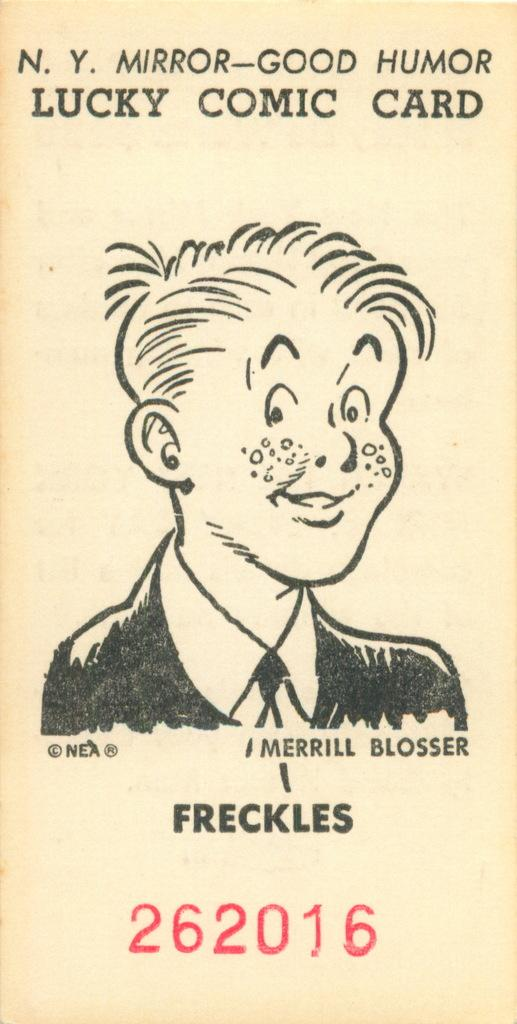Who is present in the image? There is a boy in the image. What is the boy wearing? The boy is wearing a suit. What type of toys can be seen in the image? There are no toys present in the image; it only features a boy wearing a suit. How many twigs are visible in the image? There are no twigs visible in the image. 